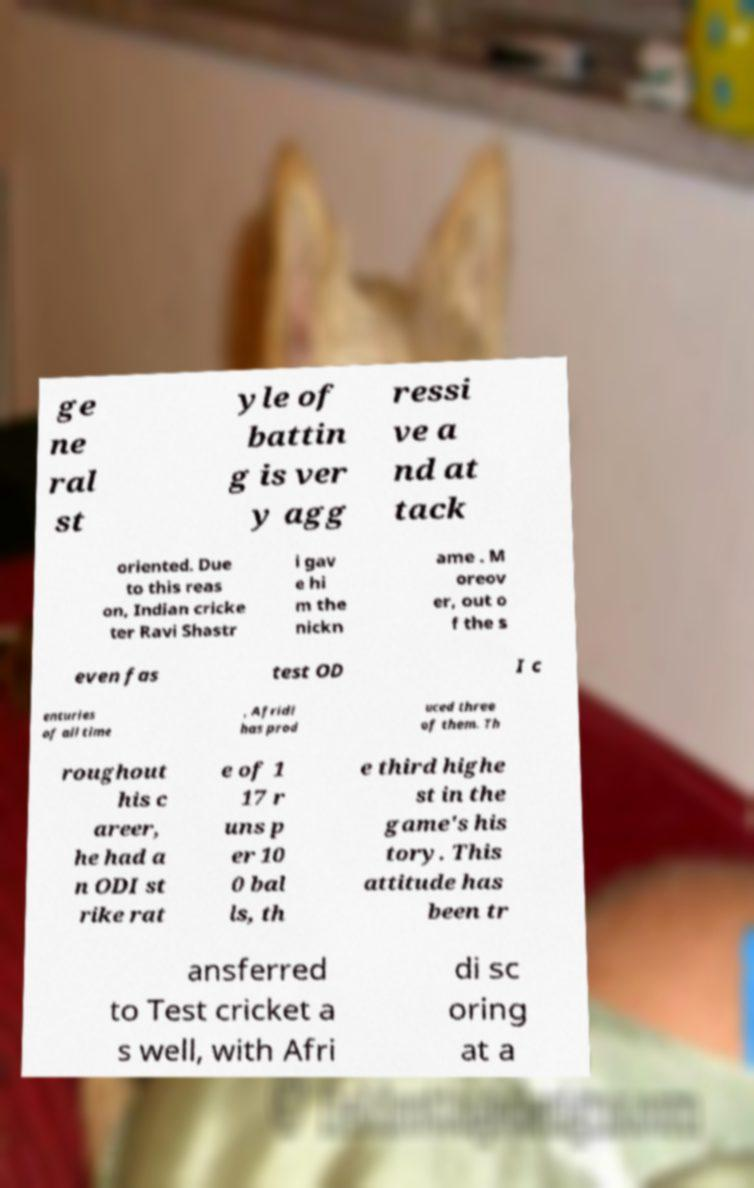For documentation purposes, I need the text within this image transcribed. Could you provide that? ge ne ral st yle of battin g is ver y agg ressi ve a nd at tack oriented. Due to this reas on, Indian cricke ter Ravi Shastr i gav e hi m the nickn ame . M oreov er, out o f the s even fas test OD I c enturies of all time , Afridi has prod uced three of them. Th roughout his c areer, he had a n ODI st rike rat e of 1 17 r uns p er 10 0 bal ls, th e third highe st in the game's his tory. This attitude has been tr ansferred to Test cricket a s well, with Afri di sc oring at a 